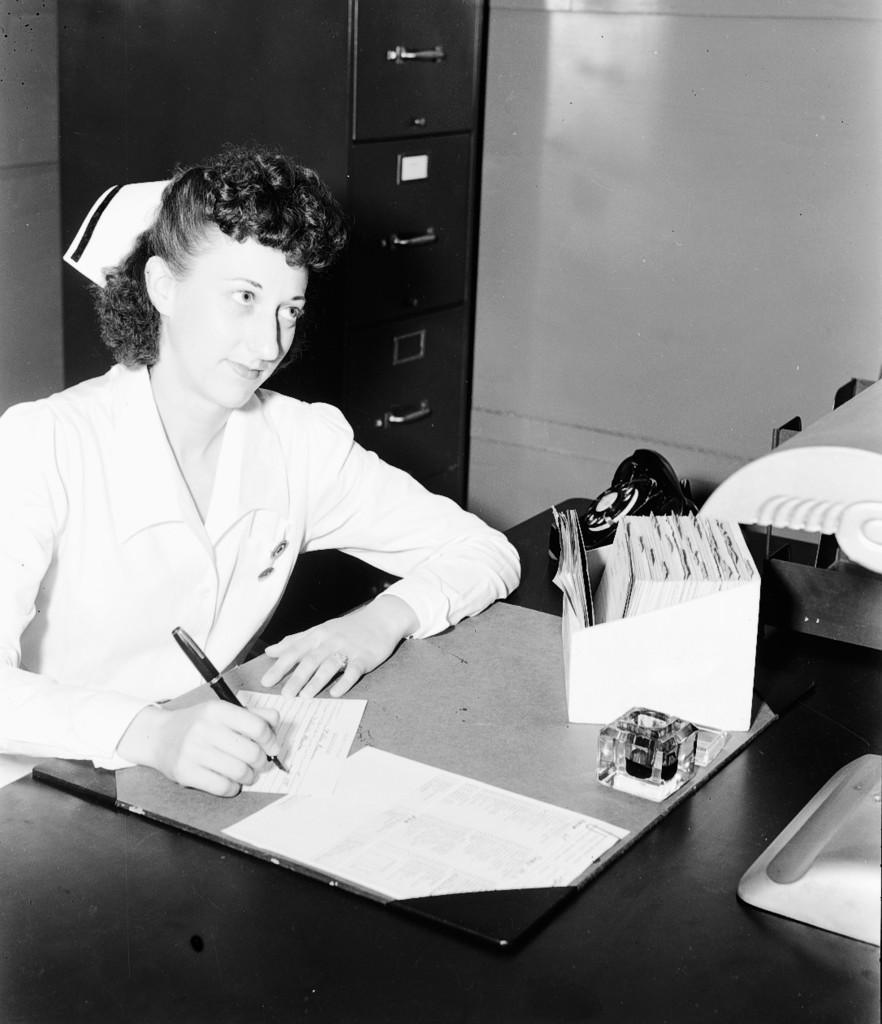Please provide a concise description of this image. In this picture we can see women wore cap, coat and smiling and she is writing with pen on paper placed on table and we can see dice, rack, telephone and in background we can see cupboard, wall. 